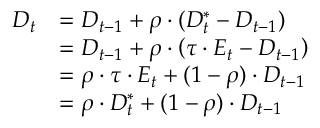Convert formula to latex. <formula><loc_0><loc_0><loc_500><loc_500>{ \begin{array} { r l } { D _ { t } } & { = D _ { t - 1 } + \rho \cdot \left ( D _ { t } ^ { * } - D _ { t - 1 } \right ) } \\ & { = D _ { t - 1 } + \rho \cdot \left ( \tau \cdot E _ { t } - D _ { t - 1 } \right ) } \\ & { = \rho \cdot \tau \cdot E _ { t } + ( 1 - \rho ) \cdot D _ { t - 1 } } \\ & { = \rho \cdot D _ { t } ^ { * } + ( 1 - \rho ) \cdot D _ { t - 1 } } \end{array} }</formula> 